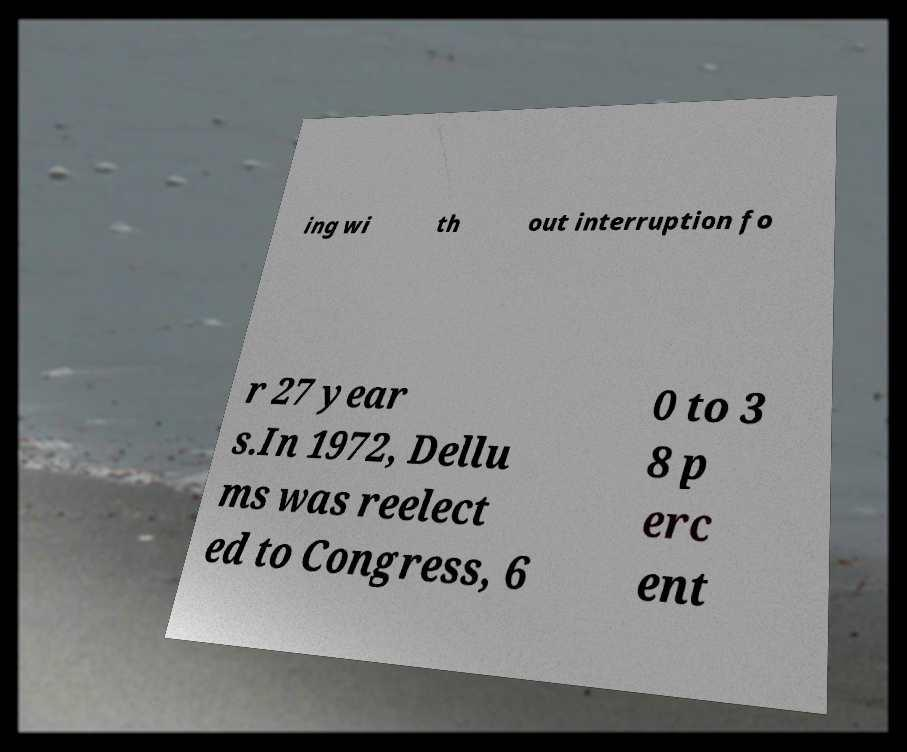Could you extract and type out the text from this image? ing wi th out interruption fo r 27 year s.In 1972, Dellu ms was reelect ed to Congress, 6 0 to 3 8 p erc ent 